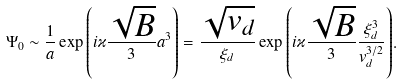Convert formula to latex. <formula><loc_0><loc_0><loc_500><loc_500>\Psi _ { 0 } \sim \frac { 1 } { a } \exp { \left ( i \varkappa \frac { \sqrt { B } } { 3 } a ^ { 3 } \right ) } = \frac { \sqrt { v _ { d } } } { \xi _ { d } } \exp { \left ( i \varkappa \frac { \sqrt { B } } { 3 } \frac { \xi ^ { 3 } _ { d } } { v ^ { 3 / 2 } _ { d } } \right ) } .</formula> 